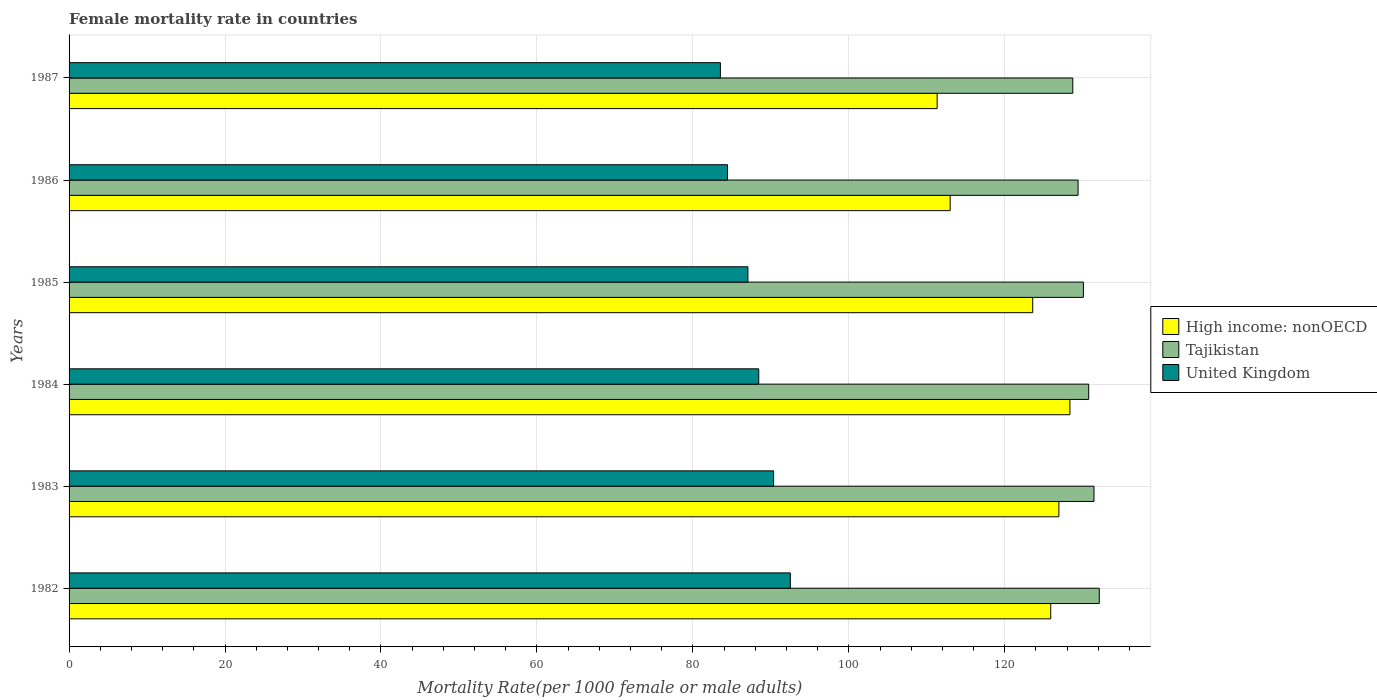How many different coloured bars are there?
Provide a succinct answer. 3. How many groups of bars are there?
Your response must be concise. 6. What is the label of the 4th group of bars from the top?
Offer a very short reply. 1984. What is the female mortality rate in Tajikistan in 1987?
Your answer should be very brief. 128.73. Across all years, what is the maximum female mortality rate in Tajikistan?
Give a very brief answer. 132.12. Across all years, what is the minimum female mortality rate in United Kingdom?
Offer a very short reply. 83.53. In which year was the female mortality rate in United Kingdom minimum?
Keep it short and to the point. 1987. What is the total female mortality rate in United Kingdom in the graph?
Ensure brevity in your answer.  526.35. What is the difference between the female mortality rate in Tajikistan in 1983 and that in 1985?
Keep it short and to the point. 1.36. What is the difference between the female mortality rate in Tajikistan in 1983 and the female mortality rate in United Kingdom in 1984?
Provide a short and direct response. 42.99. What is the average female mortality rate in Tajikistan per year?
Offer a very short reply. 130.42. In the year 1985, what is the difference between the female mortality rate in Tajikistan and female mortality rate in High income: nonOECD?
Your response must be concise. 6.5. What is the ratio of the female mortality rate in Tajikistan in 1985 to that in 1986?
Offer a very short reply. 1.01. Is the difference between the female mortality rate in Tajikistan in 1985 and 1986 greater than the difference between the female mortality rate in High income: nonOECD in 1985 and 1986?
Your answer should be compact. No. What is the difference between the highest and the second highest female mortality rate in United Kingdom?
Offer a very short reply. 2.15. What is the difference between the highest and the lowest female mortality rate in Tajikistan?
Your answer should be very brief. 3.4. In how many years, is the female mortality rate in Tajikistan greater than the average female mortality rate in Tajikistan taken over all years?
Provide a succinct answer. 3. Is the sum of the female mortality rate in High income: nonOECD in 1982 and 1986 greater than the maximum female mortality rate in Tajikistan across all years?
Your answer should be very brief. Yes. What does the 2nd bar from the top in 1986 represents?
Make the answer very short. Tajikistan. What does the 2nd bar from the bottom in 1982 represents?
Keep it short and to the point. Tajikistan. What is the difference between two consecutive major ticks on the X-axis?
Your answer should be very brief. 20. Does the graph contain any zero values?
Your answer should be very brief. No. Does the graph contain grids?
Provide a short and direct response. Yes. Where does the legend appear in the graph?
Keep it short and to the point. Center right. What is the title of the graph?
Provide a short and direct response. Female mortality rate in countries. Does "Liberia" appear as one of the legend labels in the graph?
Your response must be concise. No. What is the label or title of the X-axis?
Offer a terse response. Mortality Rate(per 1000 female or male adults). What is the label or title of the Y-axis?
Provide a succinct answer. Years. What is the Mortality Rate(per 1000 female or male adults) of High income: nonOECD in 1982?
Your answer should be compact. 125.9. What is the Mortality Rate(per 1000 female or male adults) of Tajikistan in 1982?
Provide a succinct answer. 132.12. What is the Mortality Rate(per 1000 female or male adults) in United Kingdom in 1982?
Provide a short and direct response. 92.5. What is the Mortality Rate(per 1000 female or male adults) of High income: nonOECD in 1983?
Your response must be concise. 126.94. What is the Mortality Rate(per 1000 female or male adults) in Tajikistan in 1983?
Provide a succinct answer. 131.44. What is the Mortality Rate(per 1000 female or male adults) of United Kingdom in 1983?
Your answer should be very brief. 90.36. What is the Mortality Rate(per 1000 female or male adults) in High income: nonOECD in 1984?
Keep it short and to the point. 128.36. What is the Mortality Rate(per 1000 female or male adults) of Tajikistan in 1984?
Ensure brevity in your answer.  130.76. What is the Mortality Rate(per 1000 female or male adults) in United Kingdom in 1984?
Your answer should be compact. 88.45. What is the Mortality Rate(per 1000 female or male adults) of High income: nonOECD in 1985?
Ensure brevity in your answer.  123.59. What is the Mortality Rate(per 1000 female or male adults) of Tajikistan in 1985?
Offer a terse response. 130.09. What is the Mortality Rate(per 1000 female or male adults) of United Kingdom in 1985?
Your response must be concise. 87.06. What is the Mortality Rate(per 1000 female or male adults) of High income: nonOECD in 1986?
Make the answer very short. 113. What is the Mortality Rate(per 1000 female or male adults) of Tajikistan in 1986?
Keep it short and to the point. 129.41. What is the Mortality Rate(per 1000 female or male adults) in United Kingdom in 1986?
Ensure brevity in your answer.  84.44. What is the Mortality Rate(per 1000 female or male adults) in High income: nonOECD in 1987?
Offer a very short reply. 111.33. What is the Mortality Rate(per 1000 female or male adults) in Tajikistan in 1987?
Make the answer very short. 128.73. What is the Mortality Rate(per 1000 female or male adults) in United Kingdom in 1987?
Your response must be concise. 83.53. Across all years, what is the maximum Mortality Rate(per 1000 female or male adults) in High income: nonOECD?
Offer a terse response. 128.36. Across all years, what is the maximum Mortality Rate(per 1000 female or male adults) in Tajikistan?
Make the answer very short. 132.12. Across all years, what is the maximum Mortality Rate(per 1000 female or male adults) in United Kingdom?
Make the answer very short. 92.5. Across all years, what is the minimum Mortality Rate(per 1000 female or male adults) of High income: nonOECD?
Your answer should be very brief. 111.33. Across all years, what is the minimum Mortality Rate(per 1000 female or male adults) of Tajikistan?
Your response must be concise. 128.73. Across all years, what is the minimum Mortality Rate(per 1000 female or male adults) in United Kingdom?
Offer a very short reply. 83.53. What is the total Mortality Rate(per 1000 female or male adults) in High income: nonOECD in the graph?
Ensure brevity in your answer.  729.11. What is the total Mortality Rate(per 1000 female or male adults) in Tajikistan in the graph?
Give a very brief answer. 782.55. What is the total Mortality Rate(per 1000 female or male adults) in United Kingdom in the graph?
Offer a terse response. 526.35. What is the difference between the Mortality Rate(per 1000 female or male adults) in High income: nonOECD in 1982 and that in 1983?
Ensure brevity in your answer.  -1.05. What is the difference between the Mortality Rate(per 1000 female or male adults) of Tajikistan in 1982 and that in 1983?
Give a very brief answer. 0.68. What is the difference between the Mortality Rate(per 1000 female or male adults) of United Kingdom in 1982 and that in 1983?
Keep it short and to the point. 2.15. What is the difference between the Mortality Rate(per 1000 female or male adults) of High income: nonOECD in 1982 and that in 1984?
Your answer should be very brief. -2.46. What is the difference between the Mortality Rate(per 1000 female or male adults) of Tajikistan in 1982 and that in 1984?
Ensure brevity in your answer.  1.36. What is the difference between the Mortality Rate(per 1000 female or male adults) of United Kingdom in 1982 and that in 1984?
Your answer should be compact. 4.05. What is the difference between the Mortality Rate(per 1000 female or male adults) in High income: nonOECD in 1982 and that in 1985?
Your answer should be compact. 2.31. What is the difference between the Mortality Rate(per 1000 female or male adults) of Tajikistan in 1982 and that in 1985?
Provide a succinct answer. 2.04. What is the difference between the Mortality Rate(per 1000 female or male adults) in United Kingdom in 1982 and that in 1985?
Provide a succinct answer. 5.44. What is the difference between the Mortality Rate(per 1000 female or male adults) of High income: nonOECD in 1982 and that in 1986?
Keep it short and to the point. 12.9. What is the difference between the Mortality Rate(per 1000 female or male adults) of Tajikistan in 1982 and that in 1986?
Offer a very short reply. 2.72. What is the difference between the Mortality Rate(per 1000 female or male adults) in United Kingdom in 1982 and that in 1986?
Ensure brevity in your answer.  8.06. What is the difference between the Mortality Rate(per 1000 female or male adults) in High income: nonOECD in 1982 and that in 1987?
Provide a succinct answer. 14.57. What is the difference between the Mortality Rate(per 1000 female or male adults) in Tajikistan in 1982 and that in 1987?
Provide a succinct answer. 3.4. What is the difference between the Mortality Rate(per 1000 female or male adults) in United Kingdom in 1982 and that in 1987?
Your answer should be very brief. 8.97. What is the difference between the Mortality Rate(per 1000 female or male adults) in High income: nonOECD in 1983 and that in 1984?
Your answer should be very brief. -1.41. What is the difference between the Mortality Rate(per 1000 female or male adults) of Tajikistan in 1983 and that in 1984?
Your response must be concise. 0.68. What is the difference between the Mortality Rate(per 1000 female or male adults) of United Kingdom in 1983 and that in 1984?
Provide a short and direct response. 1.91. What is the difference between the Mortality Rate(per 1000 female or male adults) in High income: nonOECD in 1983 and that in 1985?
Ensure brevity in your answer.  3.36. What is the difference between the Mortality Rate(per 1000 female or male adults) of Tajikistan in 1983 and that in 1985?
Offer a terse response. 1.36. What is the difference between the Mortality Rate(per 1000 female or male adults) in United Kingdom in 1983 and that in 1985?
Keep it short and to the point. 3.3. What is the difference between the Mortality Rate(per 1000 female or male adults) in High income: nonOECD in 1983 and that in 1986?
Keep it short and to the point. 13.94. What is the difference between the Mortality Rate(per 1000 female or male adults) in Tajikistan in 1983 and that in 1986?
Offer a terse response. 2.04. What is the difference between the Mortality Rate(per 1000 female or male adults) in United Kingdom in 1983 and that in 1986?
Make the answer very short. 5.92. What is the difference between the Mortality Rate(per 1000 female or male adults) in High income: nonOECD in 1983 and that in 1987?
Your answer should be very brief. 15.61. What is the difference between the Mortality Rate(per 1000 female or male adults) in Tajikistan in 1983 and that in 1987?
Your response must be concise. 2.72. What is the difference between the Mortality Rate(per 1000 female or male adults) of United Kingdom in 1983 and that in 1987?
Your response must be concise. 6.82. What is the difference between the Mortality Rate(per 1000 female or male adults) of High income: nonOECD in 1984 and that in 1985?
Ensure brevity in your answer.  4.77. What is the difference between the Mortality Rate(per 1000 female or male adults) of Tajikistan in 1984 and that in 1985?
Give a very brief answer. 0.68. What is the difference between the Mortality Rate(per 1000 female or male adults) of United Kingdom in 1984 and that in 1985?
Your answer should be very brief. 1.39. What is the difference between the Mortality Rate(per 1000 female or male adults) in High income: nonOECD in 1984 and that in 1986?
Your response must be concise. 15.36. What is the difference between the Mortality Rate(per 1000 female or male adults) in Tajikistan in 1984 and that in 1986?
Your answer should be very brief. 1.36. What is the difference between the Mortality Rate(per 1000 female or male adults) of United Kingdom in 1984 and that in 1986?
Offer a very short reply. 4.01. What is the difference between the Mortality Rate(per 1000 female or male adults) in High income: nonOECD in 1984 and that in 1987?
Keep it short and to the point. 17.03. What is the difference between the Mortality Rate(per 1000 female or male adults) of Tajikistan in 1984 and that in 1987?
Keep it short and to the point. 2.04. What is the difference between the Mortality Rate(per 1000 female or male adults) in United Kingdom in 1984 and that in 1987?
Give a very brief answer. 4.92. What is the difference between the Mortality Rate(per 1000 female or male adults) of High income: nonOECD in 1985 and that in 1986?
Your answer should be compact. 10.59. What is the difference between the Mortality Rate(per 1000 female or male adults) in Tajikistan in 1985 and that in 1986?
Provide a short and direct response. 0.68. What is the difference between the Mortality Rate(per 1000 female or male adults) of United Kingdom in 1985 and that in 1986?
Provide a succinct answer. 2.62. What is the difference between the Mortality Rate(per 1000 female or male adults) of High income: nonOECD in 1985 and that in 1987?
Make the answer very short. 12.26. What is the difference between the Mortality Rate(per 1000 female or male adults) in Tajikistan in 1985 and that in 1987?
Make the answer very short. 1.36. What is the difference between the Mortality Rate(per 1000 female or male adults) in United Kingdom in 1985 and that in 1987?
Your answer should be compact. 3.53. What is the difference between the Mortality Rate(per 1000 female or male adults) in High income: nonOECD in 1986 and that in 1987?
Make the answer very short. 1.67. What is the difference between the Mortality Rate(per 1000 female or male adults) in Tajikistan in 1986 and that in 1987?
Offer a terse response. 0.68. What is the difference between the Mortality Rate(per 1000 female or male adults) of United Kingdom in 1986 and that in 1987?
Make the answer very short. 0.91. What is the difference between the Mortality Rate(per 1000 female or male adults) of High income: nonOECD in 1982 and the Mortality Rate(per 1000 female or male adults) of Tajikistan in 1983?
Ensure brevity in your answer.  -5.55. What is the difference between the Mortality Rate(per 1000 female or male adults) in High income: nonOECD in 1982 and the Mortality Rate(per 1000 female or male adults) in United Kingdom in 1983?
Provide a short and direct response. 35.54. What is the difference between the Mortality Rate(per 1000 female or male adults) of Tajikistan in 1982 and the Mortality Rate(per 1000 female or male adults) of United Kingdom in 1983?
Keep it short and to the point. 41.77. What is the difference between the Mortality Rate(per 1000 female or male adults) in High income: nonOECD in 1982 and the Mortality Rate(per 1000 female or male adults) in Tajikistan in 1984?
Ensure brevity in your answer.  -4.87. What is the difference between the Mortality Rate(per 1000 female or male adults) of High income: nonOECD in 1982 and the Mortality Rate(per 1000 female or male adults) of United Kingdom in 1984?
Provide a succinct answer. 37.45. What is the difference between the Mortality Rate(per 1000 female or male adults) of Tajikistan in 1982 and the Mortality Rate(per 1000 female or male adults) of United Kingdom in 1984?
Keep it short and to the point. 43.67. What is the difference between the Mortality Rate(per 1000 female or male adults) in High income: nonOECD in 1982 and the Mortality Rate(per 1000 female or male adults) in Tajikistan in 1985?
Your answer should be compact. -4.19. What is the difference between the Mortality Rate(per 1000 female or male adults) of High income: nonOECD in 1982 and the Mortality Rate(per 1000 female or male adults) of United Kingdom in 1985?
Your response must be concise. 38.84. What is the difference between the Mortality Rate(per 1000 female or male adults) of Tajikistan in 1982 and the Mortality Rate(per 1000 female or male adults) of United Kingdom in 1985?
Keep it short and to the point. 45.06. What is the difference between the Mortality Rate(per 1000 female or male adults) of High income: nonOECD in 1982 and the Mortality Rate(per 1000 female or male adults) of Tajikistan in 1986?
Offer a terse response. -3.51. What is the difference between the Mortality Rate(per 1000 female or male adults) of High income: nonOECD in 1982 and the Mortality Rate(per 1000 female or male adults) of United Kingdom in 1986?
Ensure brevity in your answer.  41.46. What is the difference between the Mortality Rate(per 1000 female or male adults) in Tajikistan in 1982 and the Mortality Rate(per 1000 female or male adults) in United Kingdom in 1986?
Provide a short and direct response. 47.68. What is the difference between the Mortality Rate(per 1000 female or male adults) in High income: nonOECD in 1982 and the Mortality Rate(per 1000 female or male adults) in Tajikistan in 1987?
Make the answer very short. -2.83. What is the difference between the Mortality Rate(per 1000 female or male adults) of High income: nonOECD in 1982 and the Mortality Rate(per 1000 female or male adults) of United Kingdom in 1987?
Ensure brevity in your answer.  42.36. What is the difference between the Mortality Rate(per 1000 female or male adults) of Tajikistan in 1982 and the Mortality Rate(per 1000 female or male adults) of United Kingdom in 1987?
Your answer should be very brief. 48.59. What is the difference between the Mortality Rate(per 1000 female or male adults) of High income: nonOECD in 1983 and the Mortality Rate(per 1000 female or male adults) of Tajikistan in 1984?
Offer a very short reply. -3.82. What is the difference between the Mortality Rate(per 1000 female or male adults) of High income: nonOECD in 1983 and the Mortality Rate(per 1000 female or male adults) of United Kingdom in 1984?
Give a very brief answer. 38.49. What is the difference between the Mortality Rate(per 1000 female or male adults) in Tajikistan in 1983 and the Mortality Rate(per 1000 female or male adults) in United Kingdom in 1984?
Offer a terse response. 42.99. What is the difference between the Mortality Rate(per 1000 female or male adults) in High income: nonOECD in 1983 and the Mortality Rate(per 1000 female or male adults) in Tajikistan in 1985?
Keep it short and to the point. -3.14. What is the difference between the Mortality Rate(per 1000 female or male adults) in High income: nonOECD in 1983 and the Mortality Rate(per 1000 female or male adults) in United Kingdom in 1985?
Your answer should be compact. 39.88. What is the difference between the Mortality Rate(per 1000 female or male adults) of Tajikistan in 1983 and the Mortality Rate(per 1000 female or male adults) of United Kingdom in 1985?
Keep it short and to the point. 44.38. What is the difference between the Mortality Rate(per 1000 female or male adults) of High income: nonOECD in 1983 and the Mortality Rate(per 1000 female or male adults) of Tajikistan in 1986?
Offer a very short reply. -2.46. What is the difference between the Mortality Rate(per 1000 female or male adults) in High income: nonOECD in 1983 and the Mortality Rate(per 1000 female or male adults) in United Kingdom in 1986?
Offer a very short reply. 42.5. What is the difference between the Mortality Rate(per 1000 female or male adults) in Tajikistan in 1983 and the Mortality Rate(per 1000 female or male adults) in United Kingdom in 1986?
Offer a very short reply. 47. What is the difference between the Mortality Rate(per 1000 female or male adults) in High income: nonOECD in 1983 and the Mortality Rate(per 1000 female or male adults) in Tajikistan in 1987?
Provide a short and direct response. -1.78. What is the difference between the Mortality Rate(per 1000 female or male adults) of High income: nonOECD in 1983 and the Mortality Rate(per 1000 female or male adults) of United Kingdom in 1987?
Ensure brevity in your answer.  43.41. What is the difference between the Mortality Rate(per 1000 female or male adults) in Tajikistan in 1983 and the Mortality Rate(per 1000 female or male adults) in United Kingdom in 1987?
Offer a very short reply. 47.91. What is the difference between the Mortality Rate(per 1000 female or male adults) in High income: nonOECD in 1984 and the Mortality Rate(per 1000 female or male adults) in Tajikistan in 1985?
Provide a short and direct response. -1.73. What is the difference between the Mortality Rate(per 1000 female or male adults) in High income: nonOECD in 1984 and the Mortality Rate(per 1000 female or male adults) in United Kingdom in 1985?
Your answer should be very brief. 41.3. What is the difference between the Mortality Rate(per 1000 female or male adults) of Tajikistan in 1984 and the Mortality Rate(per 1000 female or male adults) of United Kingdom in 1985?
Provide a short and direct response. 43.7. What is the difference between the Mortality Rate(per 1000 female or male adults) of High income: nonOECD in 1984 and the Mortality Rate(per 1000 female or male adults) of Tajikistan in 1986?
Provide a succinct answer. -1.05. What is the difference between the Mortality Rate(per 1000 female or male adults) in High income: nonOECD in 1984 and the Mortality Rate(per 1000 female or male adults) in United Kingdom in 1986?
Your answer should be very brief. 43.92. What is the difference between the Mortality Rate(per 1000 female or male adults) in Tajikistan in 1984 and the Mortality Rate(per 1000 female or male adults) in United Kingdom in 1986?
Give a very brief answer. 46.32. What is the difference between the Mortality Rate(per 1000 female or male adults) in High income: nonOECD in 1984 and the Mortality Rate(per 1000 female or male adults) in Tajikistan in 1987?
Ensure brevity in your answer.  -0.37. What is the difference between the Mortality Rate(per 1000 female or male adults) in High income: nonOECD in 1984 and the Mortality Rate(per 1000 female or male adults) in United Kingdom in 1987?
Give a very brief answer. 44.82. What is the difference between the Mortality Rate(per 1000 female or male adults) of Tajikistan in 1984 and the Mortality Rate(per 1000 female or male adults) of United Kingdom in 1987?
Make the answer very short. 47.23. What is the difference between the Mortality Rate(per 1000 female or male adults) of High income: nonOECD in 1985 and the Mortality Rate(per 1000 female or male adults) of Tajikistan in 1986?
Provide a short and direct response. -5.82. What is the difference between the Mortality Rate(per 1000 female or male adults) of High income: nonOECD in 1985 and the Mortality Rate(per 1000 female or male adults) of United Kingdom in 1986?
Make the answer very short. 39.15. What is the difference between the Mortality Rate(per 1000 female or male adults) of Tajikistan in 1985 and the Mortality Rate(per 1000 female or male adults) of United Kingdom in 1986?
Your answer should be very brief. 45.65. What is the difference between the Mortality Rate(per 1000 female or male adults) in High income: nonOECD in 1985 and the Mortality Rate(per 1000 female or male adults) in Tajikistan in 1987?
Offer a very short reply. -5.14. What is the difference between the Mortality Rate(per 1000 female or male adults) of High income: nonOECD in 1985 and the Mortality Rate(per 1000 female or male adults) of United Kingdom in 1987?
Your answer should be compact. 40.05. What is the difference between the Mortality Rate(per 1000 female or male adults) in Tajikistan in 1985 and the Mortality Rate(per 1000 female or male adults) in United Kingdom in 1987?
Your response must be concise. 46.55. What is the difference between the Mortality Rate(per 1000 female or male adults) of High income: nonOECD in 1986 and the Mortality Rate(per 1000 female or male adults) of Tajikistan in 1987?
Keep it short and to the point. -15.73. What is the difference between the Mortality Rate(per 1000 female or male adults) of High income: nonOECD in 1986 and the Mortality Rate(per 1000 female or male adults) of United Kingdom in 1987?
Your answer should be very brief. 29.47. What is the difference between the Mortality Rate(per 1000 female or male adults) in Tajikistan in 1986 and the Mortality Rate(per 1000 female or male adults) in United Kingdom in 1987?
Offer a very short reply. 45.87. What is the average Mortality Rate(per 1000 female or male adults) in High income: nonOECD per year?
Your response must be concise. 121.52. What is the average Mortality Rate(per 1000 female or male adults) of Tajikistan per year?
Make the answer very short. 130.42. What is the average Mortality Rate(per 1000 female or male adults) in United Kingdom per year?
Give a very brief answer. 87.72. In the year 1982, what is the difference between the Mortality Rate(per 1000 female or male adults) in High income: nonOECD and Mortality Rate(per 1000 female or male adults) in Tajikistan?
Offer a terse response. -6.23. In the year 1982, what is the difference between the Mortality Rate(per 1000 female or male adults) in High income: nonOECD and Mortality Rate(per 1000 female or male adults) in United Kingdom?
Offer a terse response. 33.39. In the year 1982, what is the difference between the Mortality Rate(per 1000 female or male adults) of Tajikistan and Mortality Rate(per 1000 female or male adults) of United Kingdom?
Offer a terse response. 39.62. In the year 1983, what is the difference between the Mortality Rate(per 1000 female or male adults) in High income: nonOECD and Mortality Rate(per 1000 female or male adults) in Tajikistan?
Your response must be concise. -4.5. In the year 1983, what is the difference between the Mortality Rate(per 1000 female or male adults) in High income: nonOECD and Mortality Rate(per 1000 female or male adults) in United Kingdom?
Give a very brief answer. 36.59. In the year 1983, what is the difference between the Mortality Rate(per 1000 female or male adults) in Tajikistan and Mortality Rate(per 1000 female or male adults) in United Kingdom?
Your answer should be very brief. 41.09. In the year 1984, what is the difference between the Mortality Rate(per 1000 female or male adults) in High income: nonOECD and Mortality Rate(per 1000 female or male adults) in Tajikistan?
Provide a succinct answer. -2.41. In the year 1984, what is the difference between the Mortality Rate(per 1000 female or male adults) in High income: nonOECD and Mortality Rate(per 1000 female or male adults) in United Kingdom?
Offer a very short reply. 39.91. In the year 1984, what is the difference between the Mortality Rate(per 1000 female or male adults) in Tajikistan and Mortality Rate(per 1000 female or male adults) in United Kingdom?
Offer a terse response. 42.31. In the year 1985, what is the difference between the Mortality Rate(per 1000 female or male adults) in High income: nonOECD and Mortality Rate(per 1000 female or male adults) in Tajikistan?
Give a very brief answer. -6.5. In the year 1985, what is the difference between the Mortality Rate(per 1000 female or male adults) in High income: nonOECD and Mortality Rate(per 1000 female or male adults) in United Kingdom?
Ensure brevity in your answer.  36.53. In the year 1985, what is the difference between the Mortality Rate(per 1000 female or male adults) in Tajikistan and Mortality Rate(per 1000 female or male adults) in United Kingdom?
Your answer should be very brief. 43.02. In the year 1986, what is the difference between the Mortality Rate(per 1000 female or male adults) of High income: nonOECD and Mortality Rate(per 1000 female or male adults) of Tajikistan?
Your answer should be very brief. -16.41. In the year 1986, what is the difference between the Mortality Rate(per 1000 female or male adults) in High income: nonOECD and Mortality Rate(per 1000 female or male adults) in United Kingdom?
Ensure brevity in your answer.  28.56. In the year 1986, what is the difference between the Mortality Rate(per 1000 female or male adults) of Tajikistan and Mortality Rate(per 1000 female or male adults) of United Kingdom?
Keep it short and to the point. 44.97. In the year 1987, what is the difference between the Mortality Rate(per 1000 female or male adults) of High income: nonOECD and Mortality Rate(per 1000 female or male adults) of Tajikistan?
Ensure brevity in your answer.  -17.4. In the year 1987, what is the difference between the Mortality Rate(per 1000 female or male adults) of High income: nonOECD and Mortality Rate(per 1000 female or male adults) of United Kingdom?
Your answer should be very brief. 27.8. In the year 1987, what is the difference between the Mortality Rate(per 1000 female or male adults) in Tajikistan and Mortality Rate(per 1000 female or male adults) in United Kingdom?
Offer a terse response. 45.19. What is the ratio of the Mortality Rate(per 1000 female or male adults) in High income: nonOECD in 1982 to that in 1983?
Ensure brevity in your answer.  0.99. What is the ratio of the Mortality Rate(per 1000 female or male adults) of Tajikistan in 1982 to that in 1983?
Offer a very short reply. 1.01. What is the ratio of the Mortality Rate(per 1000 female or male adults) of United Kingdom in 1982 to that in 1983?
Make the answer very short. 1.02. What is the ratio of the Mortality Rate(per 1000 female or male adults) in High income: nonOECD in 1982 to that in 1984?
Provide a succinct answer. 0.98. What is the ratio of the Mortality Rate(per 1000 female or male adults) of Tajikistan in 1982 to that in 1984?
Offer a very short reply. 1.01. What is the ratio of the Mortality Rate(per 1000 female or male adults) in United Kingdom in 1982 to that in 1984?
Your response must be concise. 1.05. What is the ratio of the Mortality Rate(per 1000 female or male adults) in High income: nonOECD in 1982 to that in 1985?
Your response must be concise. 1.02. What is the ratio of the Mortality Rate(per 1000 female or male adults) in Tajikistan in 1982 to that in 1985?
Ensure brevity in your answer.  1.02. What is the ratio of the Mortality Rate(per 1000 female or male adults) of High income: nonOECD in 1982 to that in 1986?
Your answer should be compact. 1.11. What is the ratio of the Mortality Rate(per 1000 female or male adults) in United Kingdom in 1982 to that in 1986?
Offer a terse response. 1.1. What is the ratio of the Mortality Rate(per 1000 female or male adults) in High income: nonOECD in 1982 to that in 1987?
Provide a short and direct response. 1.13. What is the ratio of the Mortality Rate(per 1000 female or male adults) in Tajikistan in 1982 to that in 1987?
Your answer should be very brief. 1.03. What is the ratio of the Mortality Rate(per 1000 female or male adults) of United Kingdom in 1982 to that in 1987?
Your answer should be compact. 1.11. What is the ratio of the Mortality Rate(per 1000 female or male adults) of High income: nonOECD in 1983 to that in 1984?
Your answer should be very brief. 0.99. What is the ratio of the Mortality Rate(per 1000 female or male adults) of Tajikistan in 1983 to that in 1984?
Keep it short and to the point. 1.01. What is the ratio of the Mortality Rate(per 1000 female or male adults) in United Kingdom in 1983 to that in 1984?
Give a very brief answer. 1.02. What is the ratio of the Mortality Rate(per 1000 female or male adults) in High income: nonOECD in 1983 to that in 1985?
Keep it short and to the point. 1.03. What is the ratio of the Mortality Rate(per 1000 female or male adults) of Tajikistan in 1983 to that in 1985?
Make the answer very short. 1.01. What is the ratio of the Mortality Rate(per 1000 female or male adults) in United Kingdom in 1983 to that in 1985?
Your answer should be very brief. 1.04. What is the ratio of the Mortality Rate(per 1000 female or male adults) in High income: nonOECD in 1983 to that in 1986?
Provide a succinct answer. 1.12. What is the ratio of the Mortality Rate(per 1000 female or male adults) of Tajikistan in 1983 to that in 1986?
Provide a short and direct response. 1.02. What is the ratio of the Mortality Rate(per 1000 female or male adults) in United Kingdom in 1983 to that in 1986?
Your answer should be compact. 1.07. What is the ratio of the Mortality Rate(per 1000 female or male adults) of High income: nonOECD in 1983 to that in 1987?
Provide a short and direct response. 1.14. What is the ratio of the Mortality Rate(per 1000 female or male adults) in Tajikistan in 1983 to that in 1987?
Ensure brevity in your answer.  1.02. What is the ratio of the Mortality Rate(per 1000 female or male adults) of United Kingdom in 1983 to that in 1987?
Offer a very short reply. 1.08. What is the ratio of the Mortality Rate(per 1000 female or male adults) of High income: nonOECD in 1984 to that in 1985?
Your answer should be compact. 1.04. What is the ratio of the Mortality Rate(per 1000 female or male adults) of High income: nonOECD in 1984 to that in 1986?
Give a very brief answer. 1.14. What is the ratio of the Mortality Rate(per 1000 female or male adults) of Tajikistan in 1984 to that in 1986?
Your answer should be compact. 1.01. What is the ratio of the Mortality Rate(per 1000 female or male adults) in United Kingdom in 1984 to that in 1986?
Make the answer very short. 1.05. What is the ratio of the Mortality Rate(per 1000 female or male adults) of High income: nonOECD in 1984 to that in 1987?
Keep it short and to the point. 1.15. What is the ratio of the Mortality Rate(per 1000 female or male adults) of Tajikistan in 1984 to that in 1987?
Your answer should be compact. 1.02. What is the ratio of the Mortality Rate(per 1000 female or male adults) in United Kingdom in 1984 to that in 1987?
Ensure brevity in your answer.  1.06. What is the ratio of the Mortality Rate(per 1000 female or male adults) of High income: nonOECD in 1985 to that in 1986?
Your answer should be compact. 1.09. What is the ratio of the Mortality Rate(per 1000 female or male adults) in United Kingdom in 1985 to that in 1986?
Give a very brief answer. 1.03. What is the ratio of the Mortality Rate(per 1000 female or male adults) in High income: nonOECD in 1985 to that in 1987?
Make the answer very short. 1.11. What is the ratio of the Mortality Rate(per 1000 female or male adults) of Tajikistan in 1985 to that in 1987?
Provide a succinct answer. 1.01. What is the ratio of the Mortality Rate(per 1000 female or male adults) of United Kingdom in 1985 to that in 1987?
Your response must be concise. 1.04. What is the ratio of the Mortality Rate(per 1000 female or male adults) in High income: nonOECD in 1986 to that in 1987?
Keep it short and to the point. 1.01. What is the ratio of the Mortality Rate(per 1000 female or male adults) in United Kingdom in 1986 to that in 1987?
Provide a short and direct response. 1.01. What is the difference between the highest and the second highest Mortality Rate(per 1000 female or male adults) in High income: nonOECD?
Provide a succinct answer. 1.41. What is the difference between the highest and the second highest Mortality Rate(per 1000 female or male adults) in Tajikistan?
Provide a succinct answer. 0.68. What is the difference between the highest and the second highest Mortality Rate(per 1000 female or male adults) in United Kingdom?
Offer a terse response. 2.15. What is the difference between the highest and the lowest Mortality Rate(per 1000 female or male adults) of High income: nonOECD?
Ensure brevity in your answer.  17.03. What is the difference between the highest and the lowest Mortality Rate(per 1000 female or male adults) in Tajikistan?
Your response must be concise. 3.4. What is the difference between the highest and the lowest Mortality Rate(per 1000 female or male adults) in United Kingdom?
Ensure brevity in your answer.  8.97. 